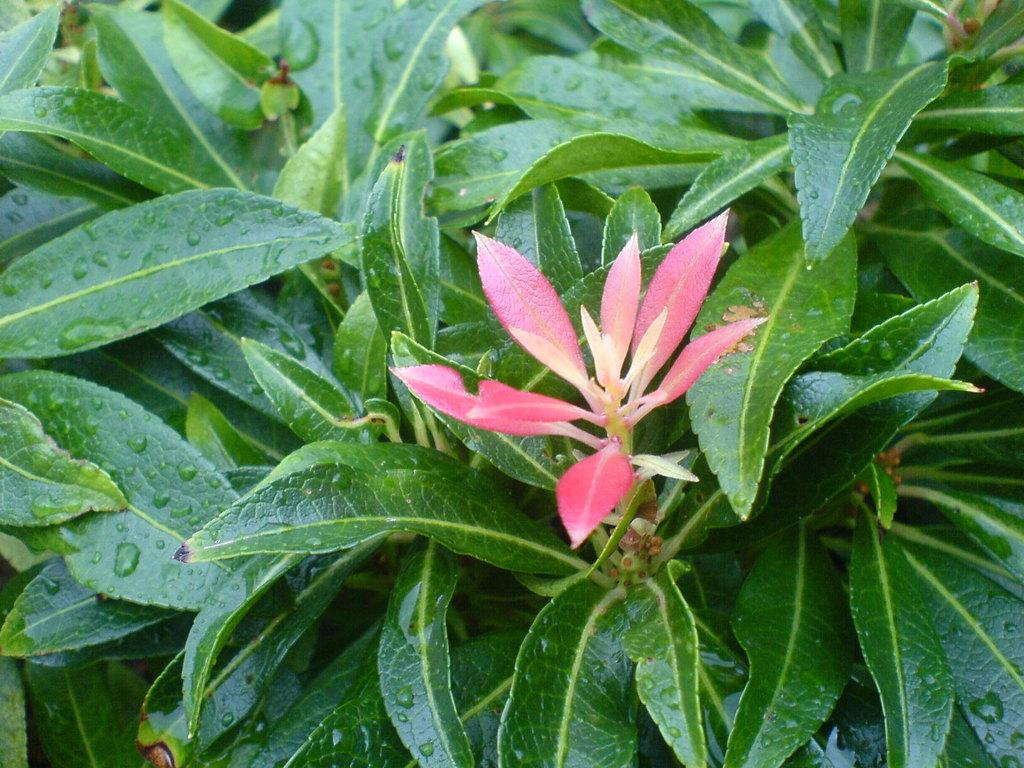What type of plant is in the picture? The picture contains a plant. What colors are present on the leaves of the plant? The plant has pink and green color leaves. Can you describe any additional details about the plant's appearance? There are water drops visible on the leaves. What channel is the plant attacking in the image? There is no channel or attack present in the image; it features a plant with pink and green leaves and water drops on them. 